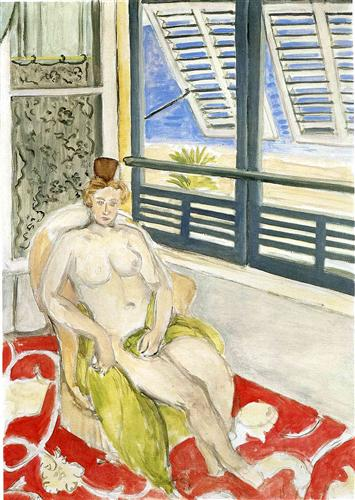What do you see happening in this image?
 The painting captures a scene of tranquility and solitude. A blonde woman, nude and adorned only with a small hat, reclines on a red and white patterned rug. The room she occupies is simple, yet vibrant, with a blue and white tiled floor that adds a touch of coolness to the warm tones of the rug. A solitary green chair stands in the room, its color contrasting with the surrounding hues. The window, framed by blue shutters, offers a glimpse of the outside world, where palm trees sway under the open sky. The painting is executed in a post-impressionist style, characterized by its bold use of color and emphasis on form over detail. The artist's brushwork is evident, adding texture and depth to the scene. Despite the simplicity of the composition, the painting conveys a sense of intimacy and quiet contemplation. 